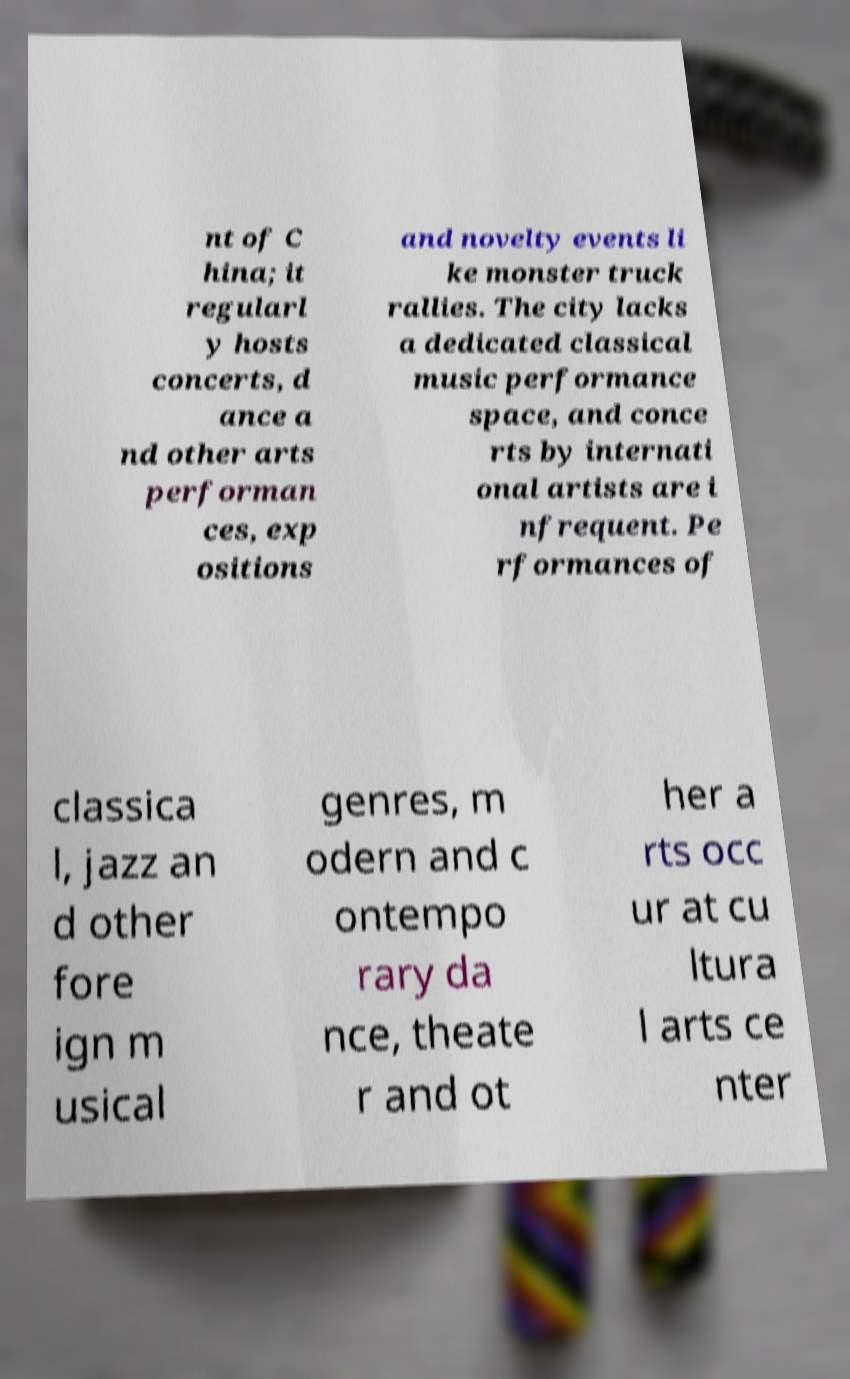There's text embedded in this image that I need extracted. Can you transcribe it verbatim? nt of C hina; it regularl y hosts concerts, d ance a nd other arts performan ces, exp ositions and novelty events li ke monster truck rallies. The city lacks a dedicated classical music performance space, and conce rts by internati onal artists are i nfrequent. Pe rformances of classica l, jazz an d other fore ign m usical genres, m odern and c ontempo rary da nce, theate r and ot her a rts occ ur at cu ltura l arts ce nter 